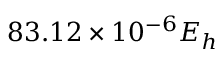Convert formula to latex. <formula><loc_0><loc_0><loc_500><loc_500>8 3 . 1 2 \times 1 0 ^ { - 6 } E _ { h }</formula> 